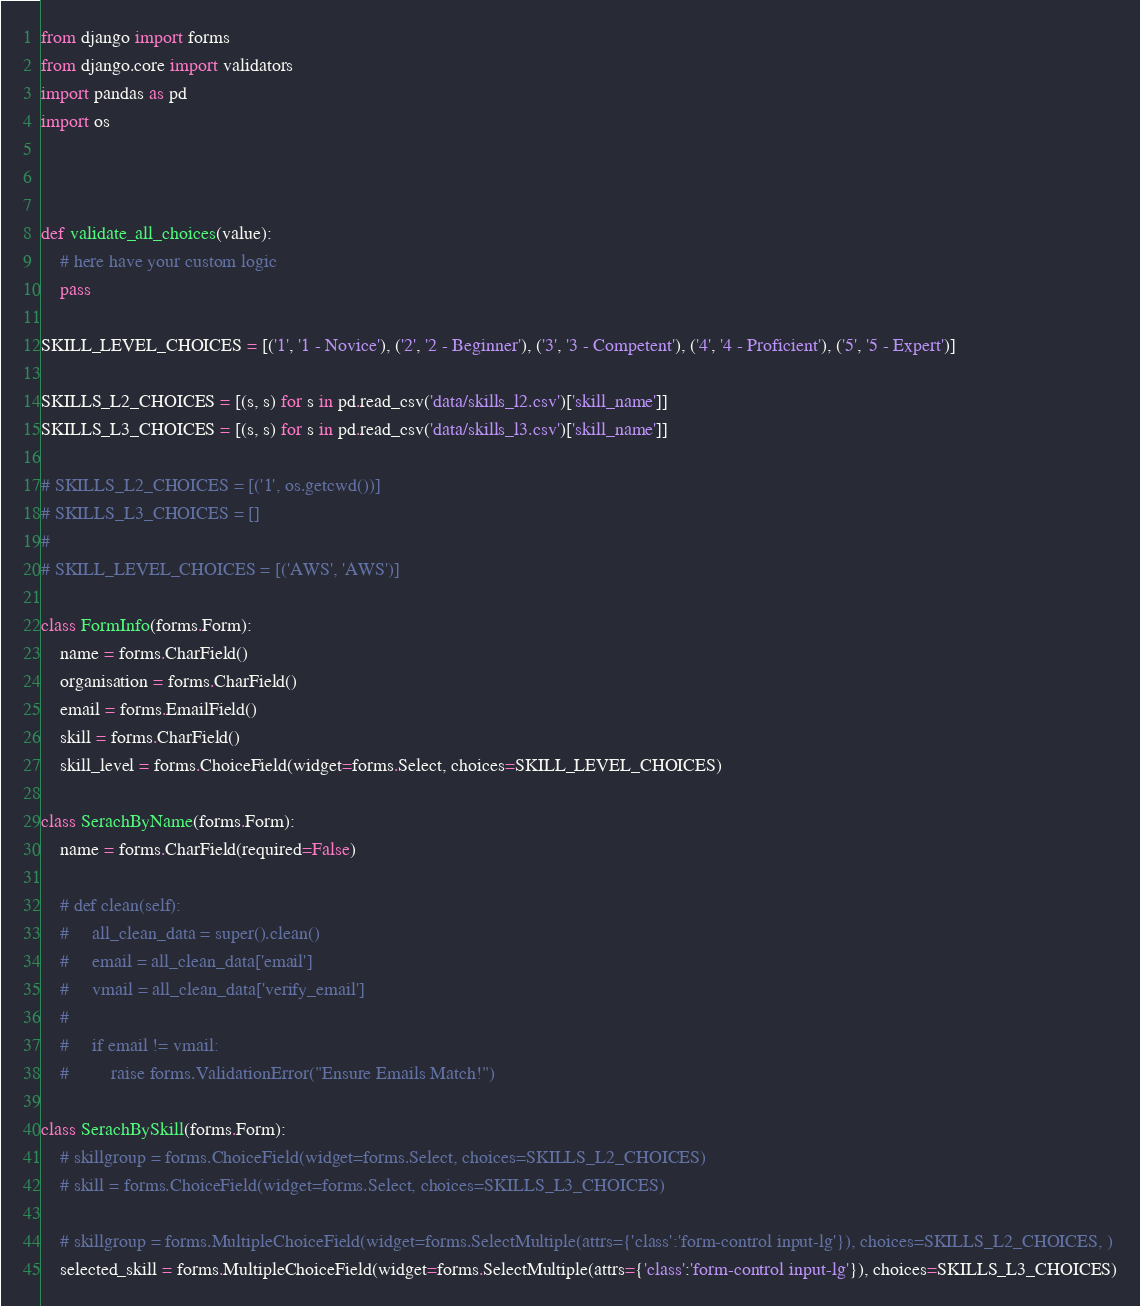<code> <loc_0><loc_0><loc_500><loc_500><_Python_>from django import forms
from django.core import validators
import pandas as pd
import os



def validate_all_choices(value):
    # here have your custom logic
    pass

SKILL_LEVEL_CHOICES = [('1', '1 - Novice'), ('2', '2 - Beginner'), ('3', '3 - Competent'), ('4', '4 - Proficient'), ('5', '5 - Expert')]

SKILLS_L2_CHOICES = [(s, s) for s in pd.read_csv('data/skills_l2.csv')['skill_name']]
SKILLS_L3_CHOICES = [(s, s) for s in pd.read_csv('data/skills_l3.csv')['skill_name']]

# SKILLS_L2_CHOICES = [('1', os.getcwd())]
# SKILLS_L3_CHOICES = []
#
# SKILL_LEVEL_CHOICES = [('AWS', 'AWS')]

class FormInfo(forms.Form):
    name = forms.CharField()
    organisation = forms.CharField()
    email = forms.EmailField()
    skill = forms.CharField()
    skill_level = forms.ChoiceField(widget=forms.Select, choices=SKILL_LEVEL_CHOICES)

class SerachByName(forms.Form):
    name = forms.CharField(required=False)

    # def clean(self):
    #     all_clean_data = super().clean()
    #     email = all_clean_data['email']
    #     vmail = all_clean_data['verify_email']
    #
    #     if email != vmail:
    #         raise forms.ValidationError("Ensure Emails Match!")

class SerachBySkill(forms.Form):
    # skillgroup = forms.ChoiceField(widget=forms.Select, choices=SKILLS_L2_CHOICES)
    # skill = forms.ChoiceField(widget=forms.Select, choices=SKILLS_L3_CHOICES)

    # skillgroup = forms.MultipleChoiceField(widget=forms.SelectMultiple(attrs={'class':'form-control input-lg'}), choices=SKILLS_L2_CHOICES, )
    selected_skill = forms.MultipleChoiceField(widget=forms.SelectMultiple(attrs={'class':'form-control input-lg'}), choices=SKILLS_L3_CHOICES)
</code> 